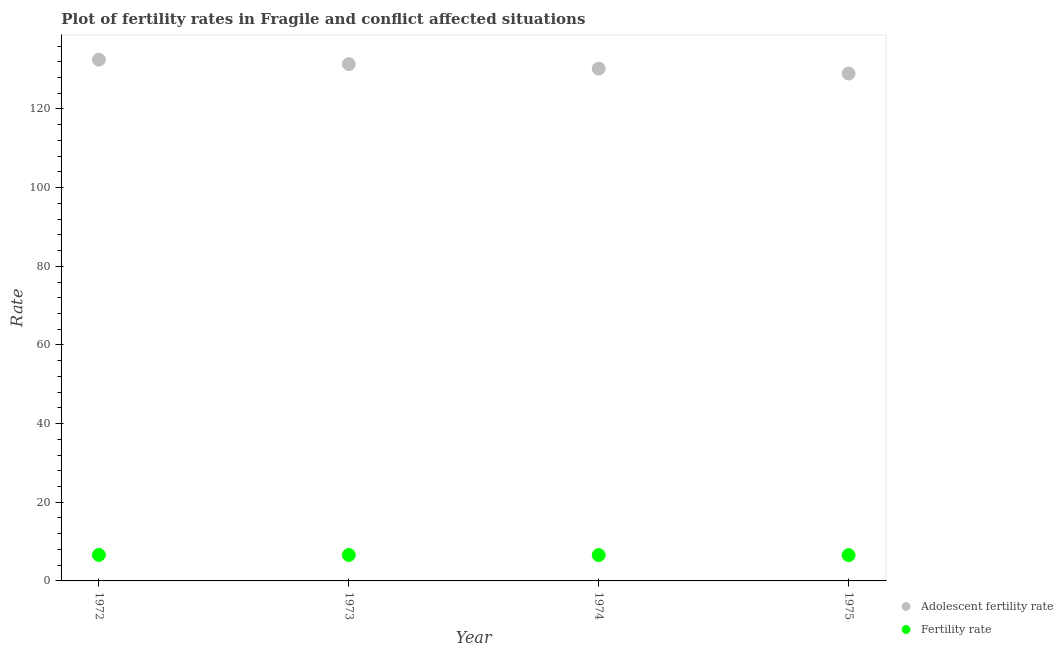How many different coloured dotlines are there?
Keep it short and to the point. 2. What is the adolescent fertility rate in 1972?
Offer a terse response. 132.54. Across all years, what is the maximum adolescent fertility rate?
Your answer should be compact. 132.54. Across all years, what is the minimum adolescent fertility rate?
Keep it short and to the point. 129.02. In which year was the adolescent fertility rate minimum?
Give a very brief answer. 1975. What is the total adolescent fertility rate in the graph?
Offer a very short reply. 523.24. What is the difference between the adolescent fertility rate in 1972 and that in 1975?
Ensure brevity in your answer.  3.52. What is the difference between the adolescent fertility rate in 1975 and the fertility rate in 1973?
Your answer should be very brief. 122.42. What is the average adolescent fertility rate per year?
Provide a succinct answer. 130.81. In the year 1975, what is the difference between the adolescent fertility rate and fertility rate?
Your answer should be very brief. 122.46. In how many years, is the fertility rate greater than 84?
Make the answer very short. 0. What is the ratio of the adolescent fertility rate in 1972 to that in 1975?
Provide a short and direct response. 1.03. Is the fertility rate in 1973 less than that in 1974?
Provide a short and direct response. No. Is the difference between the adolescent fertility rate in 1972 and 1975 greater than the difference between the fertility rate in 1972 and 1975?
Provide a short and direct response. Yes. What is the difference between the highest and the second highest adolescent fertility rate?
Provide a succinct answer. 1.13. What is the difference between the highest and the lowest adolescent fertility rate?
Keep it short and to the point. 3.52. In how many years, is the fertility rate greater than the average fertility rate taken over all years?
Provide a short and direct response. 2. Is the sum of the fertility rate in 1973 and 1975 greater than the maximum adolescent fertility rate across all years?
Give a very brief answer. No. Does the adolescent fertility rate monotonically increase over the years?
Your answer should be compact. No. Is the adolescent fertility rate strictly greater than the fertility rate over the years?
Offer a terse response. Yes. Is the adolescent fertility rate strictly less than the fertility rate over the years?
Ensure brevity in your answer.  No. How many dotlines are there?
Your answer should be very brief. 2. Are the values on the major ticks of Y-axis written in scientific E-notation?
Your response must be concise. No. Does the graph contain any zero values?
Your answer should be very brief. No. How are the legend labels stacked?
Your answer should be very brief. Vertical. What is the title of the graph?
Keep it short and to the point. Plot of fertility rates in Fragile and conflict affected situations. Does "Under five" appear as one of the legend labels in the graph?
Offer a very short reply. No. What is the label or title of the Y-axis?
Give a very brief answer. Rate. What is the Rate in Adolescent fertility rate in 1972?
Your answer should be compact. 132.54. What is the Rate of Fertility rate in 1972?
Provide a succinct answer. 6.61. What is the Rate of Adolescent fertility rate in 1973?
Your answer should be compact. 131.41. What is the Rate in Fertility rate in 1973?
Provide a succinct answer. 6.6. What is the Rate of Adolescent fertility rate in 1974?
Your response must be concise. 130.26. What is the Rate in Fertility rate in 1974?
Your answer should be compact. 6.58. What is the Rate in Adolescent fertility rate in 1975?
Your response must be concise. 129.02. What is the Rate of Fertility rate in 1975?
Keep it short and to the point. 6.56. Across all years, what is the maximum Rate in Adolescent fertility rate?
Offer a very short reply. 132.54. Across all years, what is the maximum Rate in Fertility rate?
Make the answer very short. 6.61. Across all years, what is the minimum Rate of Adolescent fertility rate?
Your answer should be very brief. 129.02. Across all years, what is the minimum Rate of Fertility rate?
Your response must be concise. 6.56. What is the total Rate of Adolescent fertility rate in the graph?
Ensure brevity in your answer.  523.24. What is the total Rate of Fertility rate in the graph?
Offer a terse response. 26.34. What is the difference between the Rate in Adolescent fertility rate in 1972 and that in 1973?
Offer a terse response. 1.13. What is the difference between the Rate in Fertility rate in 1972 and that in 1973?
Your response must be concise. 0.02. What is the difference between the Rate in Adolescent fertility rate in 1972 and that in 1974?
Provide a succinct answer. 2.28. What is the difference between the Rate of Fertility rate in 1972 and that in 1974?
Offer a very short reply. 0.04. What is the difference between the Rate in Adolescent fertility rate in 1972 and that in 1975?
Make the answer very short. 3.52. What is the difference between the Rate of Fertility rate in 1972 and that in 1975?
Ensure brevity in your answer.  0.06. What is the difference between the Rate in Adolescent fertility rate in 1973 and that in 1974?
Your response must be concise. 1.15. What is the difference between the Rate of Fertility rate in 1973 and that in 1974?
Offer a very short reply. 0.02. What is the difference between the Rate of Adolescent fertility rate in 1973 and that in 1975?
Provide a succinct answer. 2.39. What is the difference between the Rate of Fertility rate in 1973 and that in 1975?
Provide a succinct answer. 0.04. What is the difference between the Rate of Adolescent fertility rate in 1974 and that in 1975?
Offer a terse response. 1.24. What is the difference between the Rate of Fertility rate in 1974 and that in 1975?
Ensure brevity in your answer.  0.02. What is the difference between the Rate of Adolescent fertility rate in 1972 and the Rate of Fertility rate in 1973?
Ensure brevity in your answer.  125.95. What is the difference between the Rate in Adolescent fertility rate in 1972 and the Rate in Fertility rate in 1974?
Offer a terse response. 125.97. What is the difference between the Rate in Adolescent fertility rate in 1972 and the Rate in Fertility rate in 1975?
Give a very brief answer. 125.99. What is the difference between the Rate of Adolescent fertility rate in 1973 and the Rate of Fertility rate in 1974?
Offer a very short reply. 124.83. What is the difference between the Rate of Adolescent fertility rate in 1973 and the Rate of Fertility rate in 1975?
Ensure brevity in your answer.  124.85. What is the difference between the Rate in Adolescent fertility rate in 1974 and the Rate in Fertility rate in 1975?
Provide a succinct answer. 123.7. What is the average Rate of Adolescent fertility rate per year?
Your answer should be compact. 130.81. What is the average Rate in Fertility rate per year?
Your answer should be compact. 6.59. In the year 1972, what is the difference between the Rate of Adolescent fertility rate and Rate of Fertility rate?
Provide a succinct answer. 125.93. In the year 1973, what is the difference between the Rate of Adolescent fertility rate and Rate of Fertility rate?
Provide a succinct answer. 124.82. In the year 1974, what is the difference between the Rate of Adolescent fertility rate and Rate of Fertility rate?
Offer a very short reply. 123.68. In the year 1975, what is the difference between the Rate in Adolescent fertility rate and Rate in Fertility rate?
Ensure brevity in your answer.  122.46. What is the ratio of the Rate in Adolescent fertility rate in 1972 to that in 1973?
Ensure brevity in your answer.  1.01. What is the ratio of the Rate in Fertility rate in 1972 to that in 1973?
Provide a succinct answer. 1. What is the ratio of the Rate in Adolescent fertility rate in 1972 to that in 1974?
Offer a terse response. 1.02. What is the ratio of the Rate of Adolescent fertility rate in 1972 to that in 1975?
Provide a short and direct response. 1.03. What is the ratio of the Rate in Fertility rate in 1972 to that in 1975?
Provide a short and direct response. 1.01. What is the ratio of the Rate of Adolescent fertility rate in 1973 to that in 1974?
Provide a succinct answer. 1.01. What is the ratio of the Rate of Adolescent fertility rate in 1973 to that in 1975?
Provide a short and direct response. 1.02. What is the ratio of the Rate of Adolescent fertility rate in 1974 to that in 1975?
Your response must be concise. 1.01. What is the ratio of the Rate in Fertility rate in 1974 to that in 1975?
Make the answer very short. 1. What is the difference between the highest and the second highest Rate in Adolescent fertility rate?
Provide a succinct answer. 1.13. What is the difference between the highest and the second highest Rate in Fertility rate?
Your response must be concise. 0.02. What is the difference between the highest and the lowest Rate in Adolescent fertility rate?
Keep it short and to the point. 3.52. What is the difference between the highest and the lowest Rate in Fertility rate?
Offer a terse response. 0.06. 